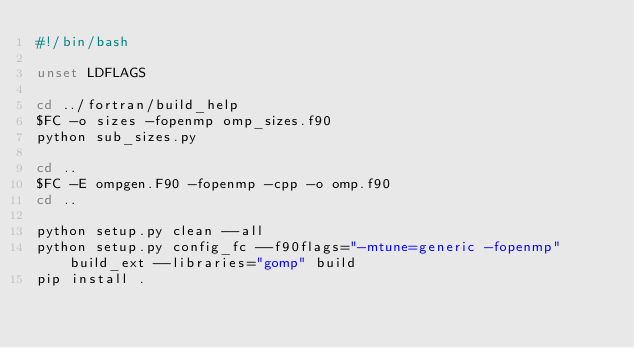<code> <loc_0><loc_0><loc_500><loc_500><_Bash_>#!/bin/bash

unset LDFLAGS

cd ../fortran/build_help
$FC -o sizes -fopenmp omp_sizes.f90
python sub_sizes.py

cd ..
$FC -E ompgen.F90 -fopenmp -cpp -o omp.f90
cd ..

python setup.py clean --all
python setup.py config_fc --f90flags="-mtune=generic -fopenmp" build_ext --libraries="gomp" build
pip install .

</code> 